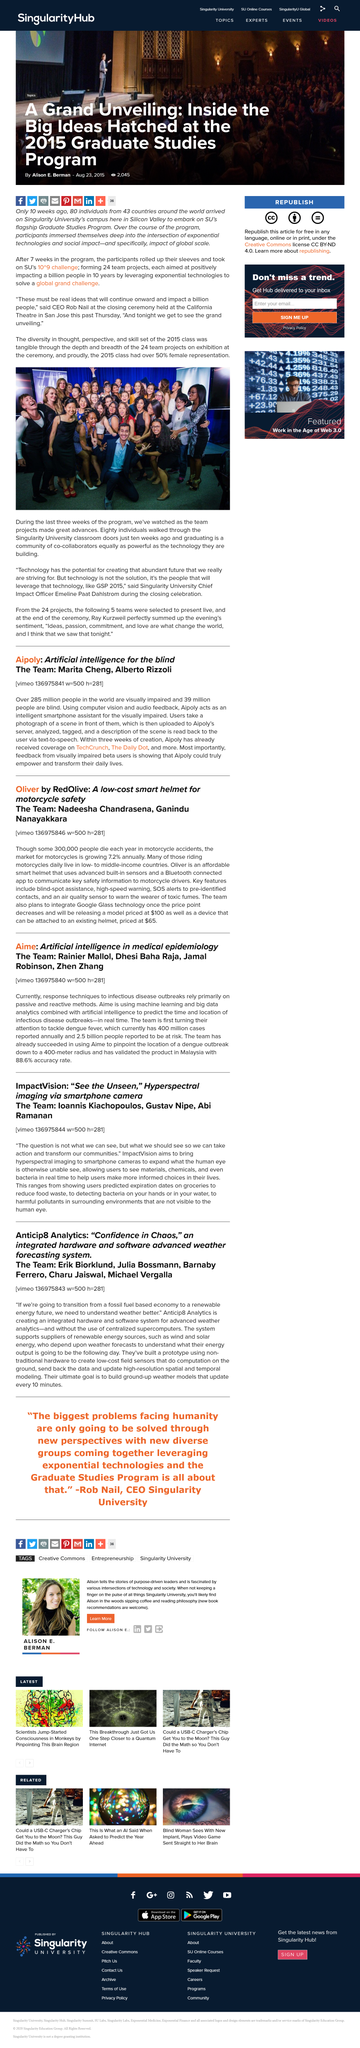Mention a couple of crucial points in this snapshot. Eighty individuals from around the world traveled to Singularity University's campus in Silicon Valley to participate in its flagship Graduate Studies Program. In the 2015 class, there was a significant amount of female representation, with over 50% of the individuals being female. The event was held at the California Theatre in San Jose. Marita Cheng and Alberto Rizzoli are members of the team developing an intelligent smartphone assistant for visually impaired individuals. It is estimated that approximately 285 million people in the world are visually impaired. 